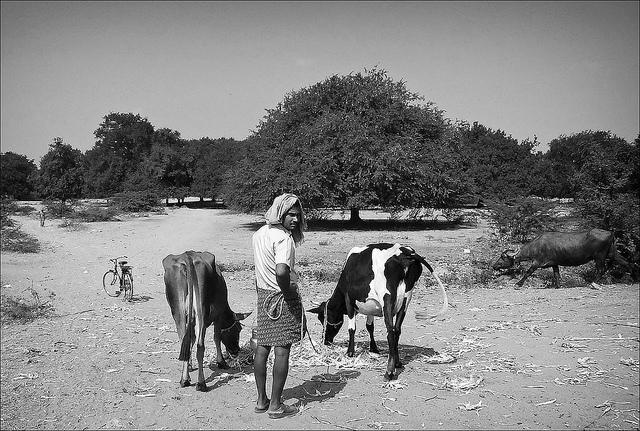Who is looking at the camera?
Quick response, please. Man. Do these animals produce dairy products?
Keep it brief. Yes. How many cows?
Answer briefly. 2. Is there a person in the distance?
Short answer required. Yes. How many legs are easily visible for the animal on the man's left?
Answer briefly. 3. Are any of the animals already eating?
Quick response, please. Yes. Are these people on the beach?
Concise answer only. No. Are the people balancing?
Answer briefly. No. Are these horses running wild?
Be succinct. No. 